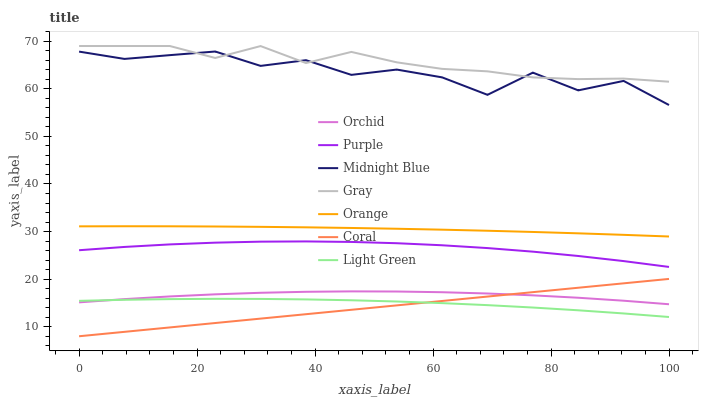Does Coral have the minimum area under the curve?
Answer yes or no. Yes. Does Gray have the maximum area under the curve?
Answer yes or no. Yes. Does Midnight Blue have the minimum area under the curve?
Answer yes or no. No. Does Midnight Blue have the maximum area under the curve?
Answer yes or no. No. Is Coral the smoothest?
Answer yes or no. Yes. Is Midnight Blue the roughest?
Answer yes or no. Yes. Is Purple the smoothest?
Answer yes or no. No. Is Purple the roughest?
Answer yes or no. No. Does Coral have the lowest value?
Answer yes or no. Yes. Does Midnight Blue have the lowest value?
Answer yes or no. No. Does Gray have the highest value?
Answer yes or no. Yes. Does Midnight Blue have the highest value?
Answer yes or no. No. Is Orchid less than Gray?
Answer yes or no. Yes. Is Orange greater than Coral?
Answer yes or no. Yes. Does Light Green intersect Coral?
Answer yes or no. Yes. Is Light Green less than Coral?
Answer yes or no. No. Is Light Green greater than Coral?
Answer yes or no. No. Does Orchid intersect Gray?
Answer yes or no. No. 